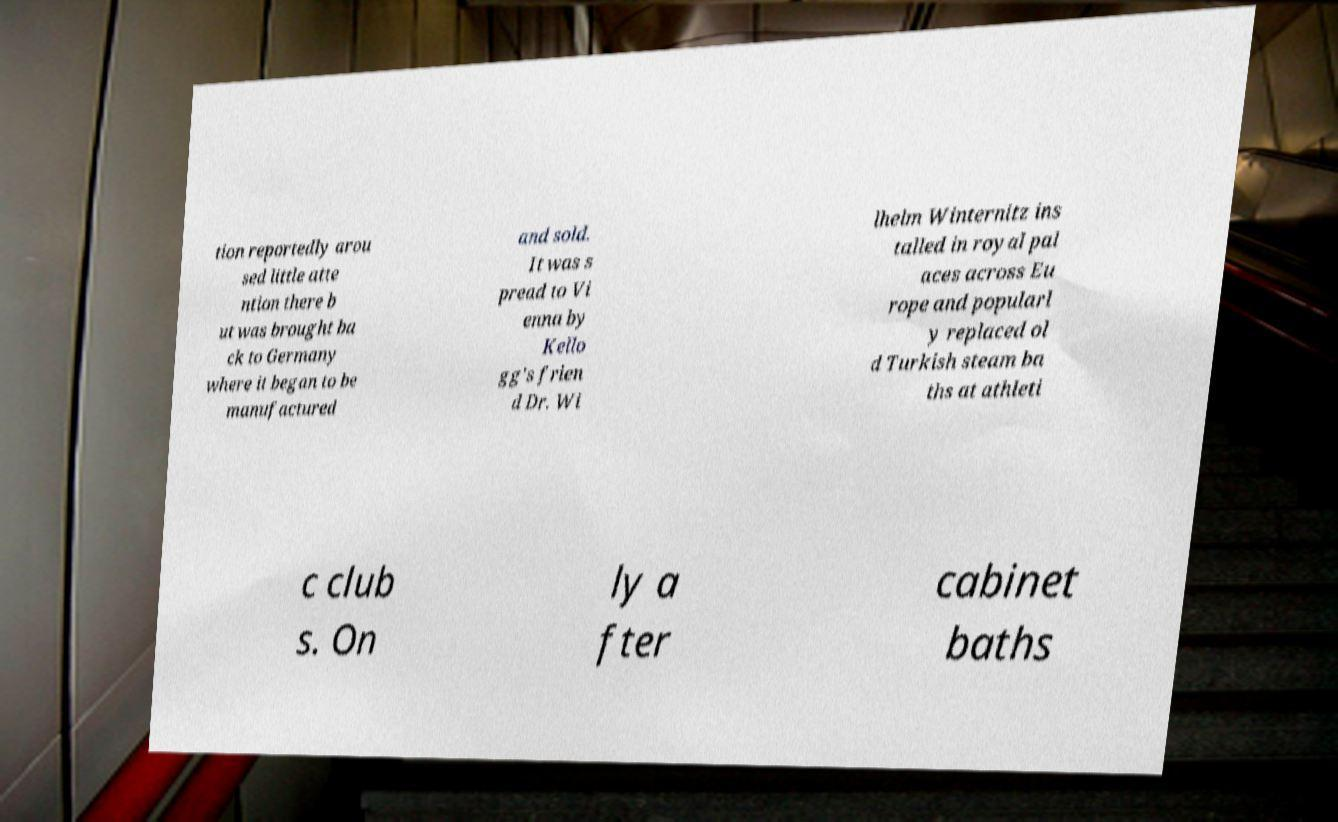Can you read and provide the text displayed in the image?This photo seems to have some interesting text. Can you extract and type it out for me? tion reportedly arou sed little atte ntion there b ut was brought ba ck to Germany where it began to be manufactured and sold. It was s pread to Vi enna by Kello gg's frien d Dr. Wi lhelm Winternitz ins talled in royal pal aces across Eu rope and popularl y replaced ol d Turkish steam ba ths at athleti c club s. On ly a fter cabinet baths 